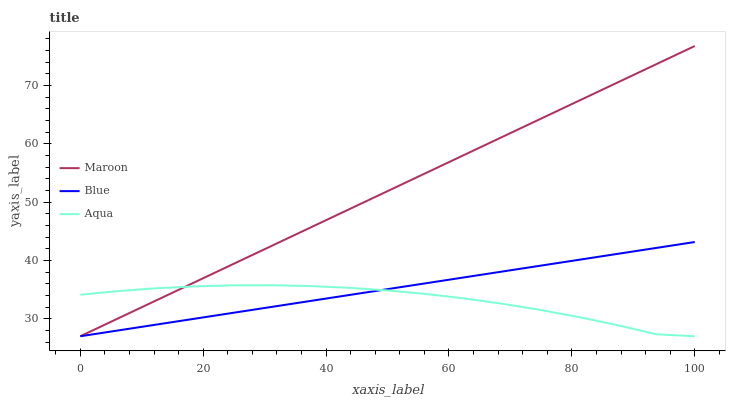Does Aqua have the minimum area under the curve?
Answer yes or no. Yes. Does Maroon have the maximum area under the curve?
Answer yes or no. Yes. Does Maroon have the minimum area under the curve?
Answer yes or no. No. Does Aqua have the maximum area under the curve?
Answer yes or no. No. Is Blue the smoothest?
Answer yes or no. Yes. Is Aqua the roughest?
Answer yes or no. Yes. Is Maroon the smoothest?
Answer yes or no. No. Is Maroon the roughest?
Answer yes or no. No. Does Aqua have the highest value?
Answer yes or no. No. 